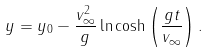Convert formula to latex. <formula><loc_0><loc_0><loc_500><loc_500>y = y _ { 0 } - { \frac { v _ { \infty } ^ { 2 } } { g } } \ln \cosh \left ( { \frac { g t } { v _ { \infty } } } \right ) .</formula> 